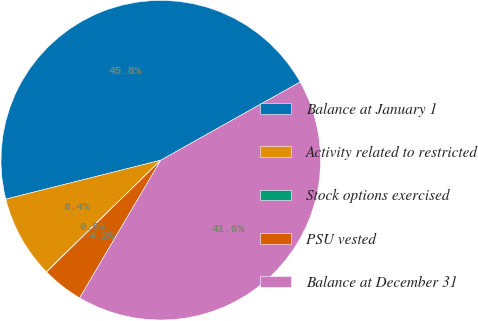Convert chart. <chart><loc_0><loc_0><loc_500><loc_500><pie_chart><fcel>Balance at January 1<fcel>Activity related to restricted<fcel>Stock options exercised<fcel>PSU vested<fcel>Balance at December 31<nl><fcel>45.78%<fcel>8.38%<fcel>0.03%<fcel>4.2%<fcel>41.61%<nl></chart> 